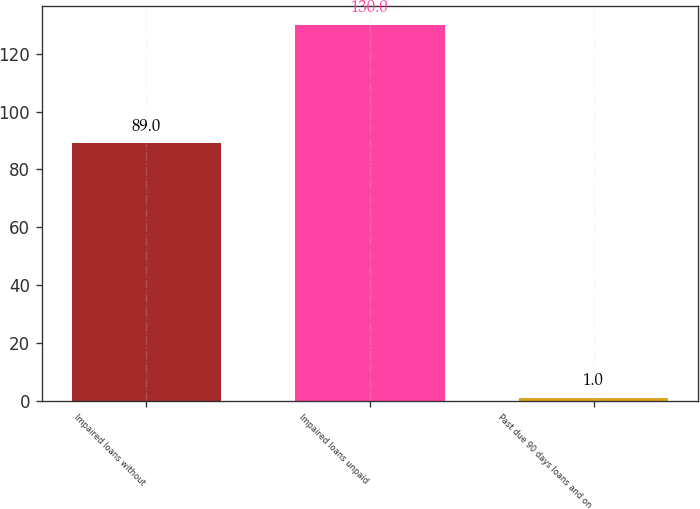Convert chart. <chart><loc_0><loc_0><loc_500><loc_500><bar_chart><fcel>Impaired loans without<fcel>Impaired loans unpaid<fcel>Past due 90 days loans and on<nl><fcel>89<fcel>130<fcel>1<nl></chart> 